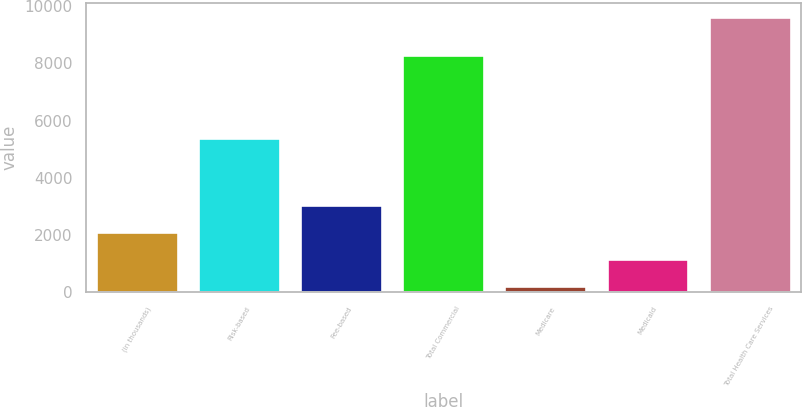Convert chart to OTSL. <chart><loc_0><loc_0><loc_500><loc_500><bar_chart><fcel>(in thousands)<fcel>Risk-based<fcel>Fee-based<fcel>Total Commercial<fcel>Medicare<fcel>Medicaid<fcel>Total Health Care Services<nl><fcel>2110<fcel>5400<fcel>3050<fcel>8295<fcel>230<fcel>1170<fcel>9630<nl></chart> 